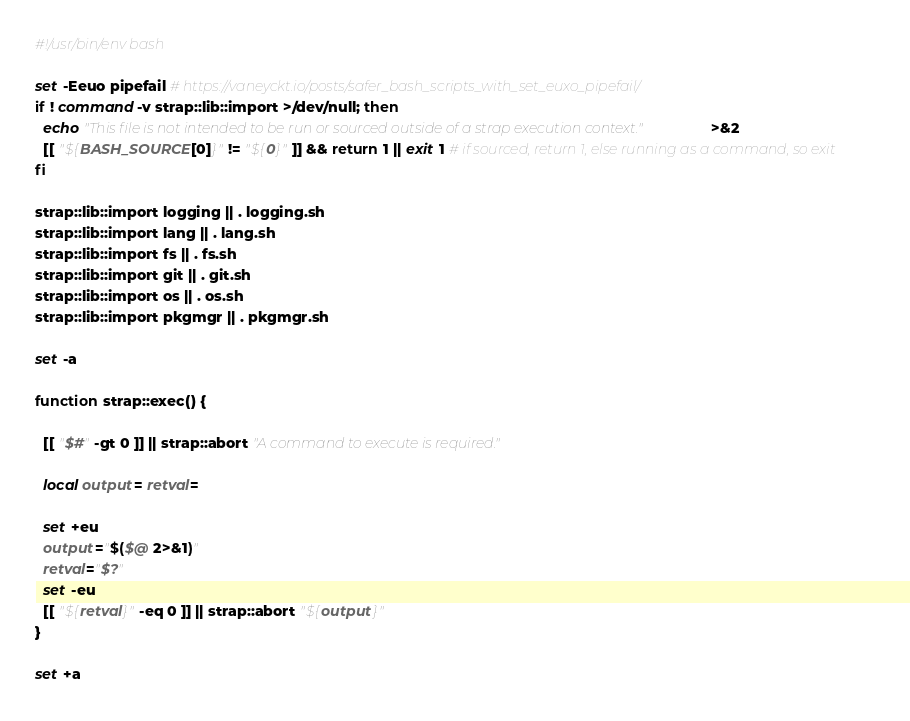Convert code to text. <code><loc_0><loc_0><loc_500><loc_500><_Bash_>#!/usr/bin/env bash

set -Eeuo pipefail # https://vaneyckt.io/posts/safer_bash_scripts_with_set_euxo_pipefail/
if ! command -v strap::lib::import >/dev/null; then
  echo "This file is not intended to be run or sourced outside of a strap execution context." >&2
  [[ "${BASH_SOURCE[0]}" != "${0}" ]] && return 1 || exit 1 # if sourced, return 1, else running as a command, so exit
fi

strap::lib::import logging || . logging.sh
strap::lib::import lang || . lang.sh
strap::lib::import fs || . fs.sh
strap::lib::import git || . git.sh
strap::lib::import os || . os.sh
strap::lib::import pkgmgr || . pkgmgr.sh

set -a

function strap::exec() {

  [[ "$#" -gt 0 ]] || strap::abort "A command to execute is required."

  local output= retval=

  set +eu
  output="$($@ 2>&1)"
  retval="$?"
  set -eu
  [[ "${retval}" -eq 0 ]] || strap::abort "${output}"
}

set +a</code> 